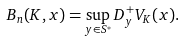Convert formula to latex. <formula><loc_0><loc_0><loc_500><loc_500>B _ { n } ( K , x ) = \sup _ { y \in S ^ { * } } D _ { y } ^ { + } V _ { K } ( x ) .</formula> 